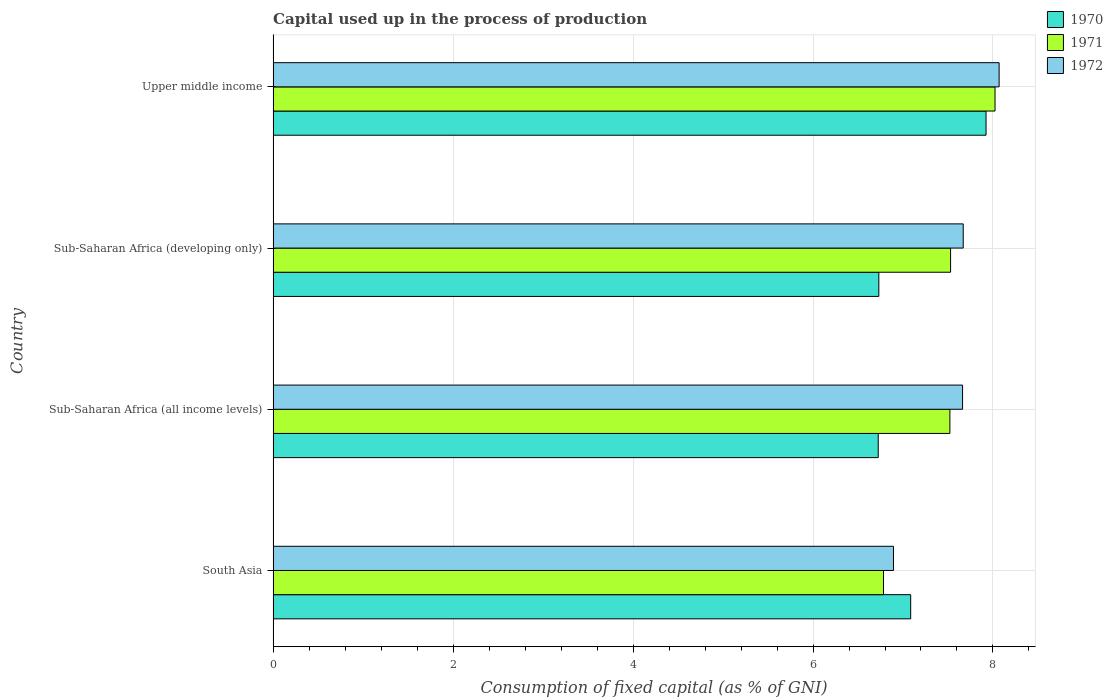How many groups of bars are there?
Ensure brevity in your answer.  4. How many bars are there on the 4th tick from the top?
Offer a terse response. 3. How many bars are there on the 2nd tick from the bottom?
Your response must be concise. 3. What is the label of the 2nd group of bars from the top?
Your response must be concise. Sub-Saharan Africa (developing only). What is the capital used up in the process of production in 1972 in South Asia?
Ensure brevity in your answer.  6.89. Across all countries, what is the maximum capital used up in the process of production in 1971?
Your response must be concise. 8.02. Across all countries, what is the minimum capital used up in the process of production in 1971?
Your answer should be compact. 6.78. In which country was the capital used up in the process of production in 1970 maximum?
Keep it short and to the point. Upper middle income. In which country was the capital used up in the process of production in 1970 minimum?
Keep it short and to the point. Sub-Saharan Africa (all income levels). What is the total capital used up in the process of production in 1972 in the graph?
Your response must be concise. 30.29. What is the difference between the capital used up in the process of production in 1970 in South Asia and that in Sub-Saharan Africa (developing only)?
Give a very brief answer. 0.35. What is the difference between the capital used up in the process of production in 1971 in Upper middle income and the capital used up in the process of production in 1970 in Sub-Saharan Africa (all income levels)?
Provide a short and direct response. 1.3. What is the average capital used up in the process of production in 1970 per country?
Offer a very short reply. 7.12. What is the difference between the capital used up in the process of production in 1970 and capital used up in the process of production in 1972 in Sub-Saharan Africa (all income levels)?
Give a very brief answer. -0.94. In how many countries, is the capital used up in the process of production in 1970 greater than 3.6 %?
Give a very brief answer. 4. What is the ratio of the capital used up in the process of production in 1970 in Sub-Saharan Africa (all income levels) to that in Sub-Saharan Africa (developing only)?
Offer a very short reply. 1. Is the capital used up in the process of production in 1970 in Sub-Saharan Africa (developing only) less than that in Upper middle income?
Make the answer very short. Yes. What is the difference between the highest and the second highest capital used up in the process of production in 1970?
Give a very brief answer. 0.84. What is the difference between the highest and the lowest capital used up in the process of production in 1970?
Keep it short and to the point. 1.2. What does the 3rd bar from the bottom in Upper middle income represents?
Provide a short and direct response. 1972. How many bars are there?
Provide a short and direct response. 12. How many countries are there in the graph?
Keep it short and to the point. 4. What is the difference between two consecutive major ticks on the X-axis?
Give a very brief answer. 2. Are the values on the major ticks of X-axis written in scientific E-notation?
Your answer should be compact. No. How are the legend labels stacked?
Provide a succinct answer. Vertical. What is the title of the graph?
Your answer should be compact. Capital used up in the process of production. Does "1960" appear as one of the legend labels in the graph?
Your response must be concise. No. What is the label or title of the X-axis?
Provide a short and direct response. Consumption of fixed capital (as % of GNI). What is the Consumption of fixed capital (as % of GNI) in 1970 in South Asia?
Ensure brevity in your answer.  7.09. What is the Consumption of fixed capital (as % of GNI) of 1971 in South Asia?
Your answer should be compact. 6.78. What is the Consumption of fixed capital (as % of GNI) of 1972 in South Asia?
Offer a very short reply. 6.89. What is the Consumption of fixed capital (as % of GNI) in 1970 in Sub-Saharan Africa (all income levels)?
Your answer should be compact. 6.72. What is the Consumption of fixed capital (as % of GNI) in 1971 in Sub-Saharan Africa (all income levels)?
Provide a short and direct response. 7.52. What is the Consumption of fixed capital (as % of GNI) in 1972 in Sub-Saharan Africa (all income levels)?
Give a very brief answer. 7.66. What is the Consumption of fixed capital (as % of GNI) of 1970 in Sub-Saharan Africa (developing only)?
Offer a terse response. 6.73. What is the Consumption of fixed capital (as % of GNI) of 1971 in Sub-Saharan Africa (developing only)?
Make the answer very short. 7.53. What is the Consumption of fixed capital (as % of GNI) of 1972 in Sub-Saharan Africa (developing only)?
Give a very brief answer. 7.67. What is the Consumption of fixed capital (as % of GNI) in 1970 in Upper middle income?
Give a very brief answer. 7.92. What is the Consumption of fixed capital (as % of GNI) in 1971 in Upper middle income?
Your answer should be very brief. 8.02. What is the Consumption of fixed capital (as % of GNI) in 1972 in Upper middle income?
Your answer should be compact. 8.07. Across all countries, what is the maximum Consumption of fixed capital (as % of GNI) in 1970?
Keep it short and to the point. 7.92. Across all countries, what is the maximum Consumption of fixed capital (as % of GNI) in 1971?
Offer a very short reply. 8.02. Across all countries, what is the maximum Consumption of fixed capital (as % of GNI) of 1972?
Your answer should be very brief. 8.07. Across all countries, what is the minimum Consumption of fixed capital (as % of GNI) of 1970?
Give a very brief answer. 6.72. Across all countries, what is the minimum Consumption of fixed capital (as % of GNI) in 1971?
Offer a very short reply. 6.78. Across all countries, what is the minimum Consumption of fixed capital (as % of GNI) in 1972?
Give a very brief answer. 6.89. What is the total Consumption of fixed capital (as % of GNI) of 1970 in the graph?
Your answer should be compact. 28.46. What is the total Consumption of fixed capital (as % of GNI) of 1971 in the graph?
Your answer should be very brief. 29.86. What is the total Consumption of fixed capital (as % of GNI) in 1972 in the graph?
Provide a succinct answer. 30.29. What is the difference between the Consumption of fixed capital (as % of GNI) of 1970 in South Asia and that in Sub-Saharan Africa (all income levels)?
Your answer should be compact. 0.36. What is the difference between the Consumption of fixed capital (as % of GNI) in 1971 in South Asia and that in Sub-Saharan Africa (all income levels)?
Offer a terse response. -0.74. What is the difference between the Consumption of fixed capital (as % of GNI) in 1972 in South Asia and that in Sub-Saharan Africa (all income levels)?
Provide a short and direct response. -0.77. What is the difference between the Consumption of fixed capital (as % of GNI) of 1970 in South Asia and that in Sub-Saharan Africa (developing only)?
Provide a short and direct response. 0.35. What is the difference between the Consumption of fixed capital (as % of GNI) in 1971 in South Asia and that in Sub-Saharan Africa (developing only)?
Your response must be concise. -0.75. What is the difference between the Consumption of fixed capital (as % of GNI) of 1972 in South Asia and that in Sub-Saharan Africa (developing only)?
Make the answer very short. -0.77. What is the difference between the Consumption of fixed capital (as % of GNI) in 1970 in South Asia and that in Upper middle income?
Your response must be concise. -0.84. What is the difference between the Consumption of fixed capital (as % of GNI) in 1971 in South Asia and that in Upper middle income?
Your response must be concise. -1.24. What is the difference between the Consumption of fixed capital (as % of GNI) of 1972 in South Asia and that in Upper middle income?
Provide a short and direct response. -1.17. What is the difference between the Consumption of fixed capital (as % of GNI) of 1970 in Sub-Saharan Africa (all income levels) and that in Sub-Saharan Africa (developing only)?
Make the answer very short. -0.01. What is the difference between the Consumption of fixed capital (as % of GNI) of 1971 in Sub-Saharan Africa (all income levels) and that in Sub-Saharan Africa (developing only)?
Offer a terse response. -0.01. What is the difference between the Consumption of fixed capital (as % of GNI) in 1972 in Sub-Saharan Africa (all income levels) and that in Sub-Saharan Africa (developing only)?
Your answer should be compact. -0.01. What is the difference between the Consumption of fixed capital (as % of GNI) of 1970 in Sub-Saharan Africa (all income levels) and that in Upper middle income?
Give a very brief answer. -1.2. What is the difference between the Consumption of fixed capital (as % of GNI) in 1971 in Sub-Saharan Africa (all income levels) and that in Upper middle income?
Your response must be concise. -0.5. What is the difference between the Consumption of fixed capital (as % of GNI) of 1972 in Sub-Saharan Africa (all income levels) and that in Upper middle income?
Your answer should be compact. -0.41. What is the difference between the Consumption of fixed capital (as % of GNI) of 1970 in Sub-Saharan Africa (developing only) and that in Upper middle income?
Offer a terse response. -1.19. What is the difference between the Consumption of fixed capital (as % of GNI) in 1971 in Sub-Saharan Africa (developing only) and that in Upper middle income?
Give a very brief answer. -0.49. What is the difference between the Consumption of fixed capital (as % of GNI) in 1972 in Sub-Saharan Africa (developing only) and that in Upper middle income?
Offer a terse response. -0.4. What is the difference between the Consumption of fixed capital (as % of GNI) of 1970 in South Asia and the Consumption of fixed capital (as % of GNI) of 1971 in Sub-Saharan Africa (all income levels)?
Provide a succinct answer. -0.44. What is the difference between the Consumption of fixed capital (as % of GNI) of 1970 in South Asia and the Consumption of fixed capital (as % of GNI) of 1972 in Sub-Saharan Africa (all income levels)?
Offer a very short reply. -0.58. What is the difference between the Consumption of fixed capital (as % of GNI) of 1971 in South Asia and the Consumption of fixed capital (as % of GNI) of 1972 in Sub-Saharan Africa (all income levels)?
Give a very brief answer. -0.88. What is the difference between the Consumption of fixed capital (as % of GNI) in 1970 in South Asia and the Consumption of fixed capital (as % of GNI) in 1971 in Sub-Saharan Africa (developing only)?
Your answer should be compact. -0.44. What is the difference between the Consumption of fixed capital (as % of GNI) of 1970 in South Asia and the Consumption of fixed capital (as % of GNI) of 1972 in Sub-Saharan Africa (developing only)?
Provide a succinct answer. -0.58. What is the difference between the Consumption of fixed capital (as % of GNI) of 1971 in South Asia and the Consumption of fixed capital (as % of GNI) of 1972 in Sub-Saharan Africa (developing only)?
Your answer should be very brief. -0.89. What is the difference between the Consumption of fixed capital (as % of GNI) in 1970 in South Asia and the Consumption of fixed capital (as % of GNI) in 1971 in Upper middle income?
Ensure brevity in your answer.  -0.94. What is the difference between the Consumption of fixed capital (as % of GNI) of 1970 in South Asia and the Consumption of fixed capital (as % of GNI) of 1972 in Upper middle income?
Keep it short and to the point. -0.98. What is the difference between the Consumption of fixed capital (as % of GNI) in 1971 in South Asia and the Consumption of fixed capital (as % of GNI) in 1972 in Upper middle income?
Ensure brevity in your answer.  -1.28. What is the difference between the Consumption of fixed capital (as % of GNI) of 1970 in Sub-Saharan Africa (all income levels) and the Consumption of fixed capital (as % of GNI) of 1971 in Sub-Saharan Africa (developing only)?
Provide a succinct answer. -0.8. What is the difference between the Consumption of fixed capital (as % of GNI) in 1970 in Sub-Saharan Africa (all income levels) and the Consumption of fixed capital (as % of GNI) in 1972 in Sub-Saharan Africa (developing only)?
Make the answer very short. -0.94. What is the difference between the Consumption of fixed capital (as % of GNI) of 1971 in Sub-Saharan Africa (all income levels) and the Consumption of fixed capital (as % of GNI) of 1972 in Sub-Saharan Africa (developing only)?
Your answer should be compact. -0.15. What is the difference between the Consumption of fixed capital (as % of GNI) in 1970 in Sub-Saharan Africa (all income levels) and the Consumption of fixed capital (as % of GNI) in 1971 in Upper middle income?
Ensure brevity in your answer.  -1.3. What is the difference between the Consumption of fixed capital (as % of GNI) of 1970 in Sub-Saharan Africa (all income levels) and the Consumption of fixed capital (as % of GNI) of 1972 in Upper middle income?
Keep it short and to the point. -1.34. What is the difference between the Consumption of fixed capital (as % of GNI) of 1971 in Sub-Saharan Africa (all income levels) and the Consumption of fixed capital (as % of GNI) of 1972 in Upper middle income?
Your response must be concise. -0.55. What is the difference between the Consumption of fixed capital (as % of GNI) in 1970 in Sub-Saharan Africa (developing only) and the Consumption of fixed capital (as % of GNI) in 1971 in Upper middle income?
Offer a terse response. -1.29. What is the difference between the Consumption of fixed capital (as % of GNI) of 1970 in Sub-Saharan Africa (developing only) and the Consumption of fixed capital (as % of GNI) of 1972 in Upper middle income?
Offer a terse response. -1.34. What is the difference between the Consumption of fixed capital (as % of GNI) in 1971 in Sub-Saharan Africa (developing only) and the Consumption of fixed capital (as % of GNI) in 1972 in Upper middle income?
Your answer should be very brief. -0.54. What is the average Consumption of fixed capital (as % of GNI) in 1970 per country?
Offer a very short reply. 7.12. What is the average Consumption of fixed capital (as % of GNI) in 1971 per country?
Provide a short and direct response. 7.46. What is the average Consumption of fixed capital (as % of GNI) of 1972 per country?
Give a very brief answer. 7.57. What is the difference between the Consumption of fixed capital (as % of GNI) in 1970 and Consumption of fixed capital (as % of GNI) in 1971 in South Asia?
Keep it short and to the point. 0.3. What is the difference between the Consumption of fixed capital (as % of GNI) in 1970 and Consumption of fixed capital (as % of GNI) in 1972 in South Asia?
Provide a succinct answer. 0.19. What is the difference between the Consumption of fixed capital (as % of GNI) of 1971 and Consumption of fixed capital (as % of GNI) of 1972 in South Asia?
Offer a terse response. -0.11. What is the difference between the Consumption of fixed capital (as % of GNI) of 1970 and Consumption of fixed capital (as % of GNI) of 1971 in Sub-Saharan Africa (all income levels)?
Give a very brief answer. -0.8. What is the difference between the Consumption of fixed capital (as % of GNI) in 1970 and Consumption of fixed capital (as % of GNI) in 1972 in Sub-Saharan Africa (all income levels)?
Give a very brief answer. -0.94. What is the difference between the Consumption of fixed capital (as % of GNI) in 1971 and Consumption of fixed capital (as % of GNI) in 1972 in Sub-Saharan Africa (all income levels)?
Offer a very short reply. -0.14. What is the difference between the Consumption of fixed capital (as % of GNI) in 1970 and Consumption of fixed capital (as % of GNI) in 1971 in Sub-Saharan Africa (developing only)?
Provide a succinct answer. -0.8. What is the difference between the Consumption of fixed capital (as % of GNI) of 1970 and Consumption of fixed capital (as % of GNI) of 1972 in Sub-Saharan Africa (developing only)?
Give a very brief answer. -0.94. What is the difference between the Consumption of fixed capital (as % of GNI) of 1971 and Consumption of fixed capital (as % of GNI) of 1972 in Sub-Saharan Africa (developing only)?
Keep it short and to the point. -0.14. What is the difference between the Consumption of fixed capital (as % of GNI) of 1970 and Consumption of fixed capital (as % of GNI) of 1971 in Upper middle income?
Provide a succinct answer. -0.1. What is the difference between the Consumption of fixed capital (as % of GNI) of 1970 and Consumption of fixed capital (as % of GNI) of 1972 in Upper middle income?
Make the answer very short. -0.15. What is the difference between the Consumption of fixed capital (as % of GNI) of 1971 and Consumption of fixed capital (as % of GNI) of 1972 in Upper middle income?
Give a very brief answer. -0.05. What is the ratio of the Consumption of fixed capital (as % of GNI) in 1970 in South Asia to that in Sub-Saharan Africa (all income levels)?
Keep it short and to the point. 1.05. What is the ratio of the Consumption of fixed capital (as % of GNI) of 1971 in South Asia to that in Sub-Saharan Africa (all income levels)?
Your answer should be very brief. 0.9. What is the ratio of the Consumption of fixed capital (as % of GNI) in 1972 in South Asia to that in Sub-Saharan Africa (all income levels)?
Provide a succinct answer. 0.9. What is the ratio of the Consumption of fixed capital (as % of GNI) of 1970 in South Asia to that in Sub-Saharan Africa (developing only)?
Offer a very short reply. 1.05. What is the ratio of the Consumption of fixed capital (as % of GNI) of 1971 in South Asia to that in Sub-Saharan Africa (developing only)?
Provide a short and direct response. 0.9. What is the ratio of the Consumption of fixed capital (as % of GNI) in 1972 in South Asia to that in Sub-Saharan Africa (developing only)?
Ensure brevity in your answer.  0.9. What is the ratio of the Consumption of fixed capital (as % of GNI) in 1970 in South Asia to that in Upper middle income?
Ensure brevity in your answer.  0.89. What is the ratio of the Consumption of fixed capital (as % of GNI) of 1971 in South Asia to that in Upper middle income?
Give a very brief answer. 0.85. What is the ratio of the Consumption of fixed capital (as % of GNI) of 1972 in South Asia to that in Upper middle income?
Offer a very short reply. 0.85. What is the ratio of the Consumption of fixed capital (as % of GNI) in 1970 in Sub-Saharan Africa (all income levels) to that in Sub-Saharan Africa (developing only)?
Provide a short and direct response. 1. What is the ratio of the Consumption of fixed capital (as % of GNI) in 1971 in Sub-Saharan Africa (all income levels) to that in Sub-Saharan Africa (developing only)?
Provide a short and direct response. 1. What is the ratio of the Consumption of fixed capital (as % of GNI) in 1972 in Sub-Saharan Africa (all income levels) to that in Sub-Saharan Africa (developing only)?
Your answer should be compact. 1. What is the ratio of the Consumption of fixed capital (as % of GNI) of 1970 in Sub-Saharan Africa (all income levels) to that in Upper middle income?
Provide a succinct answer. 0.85. What is the ratio of the Consumption of fixed capital (as % of GNI) in 1972 in Sub-Saharan Africa (all income levels) to that in Upper middle income?
Your answer should be compact. 0.95. What is the ratio of the Consumption of fixed capital (as % of GNI) of 1970 in Sub-Saharan Africa (developing only) to that in Upper middle income?
Your answer should be compact. 0.85. What is the ratio of the Consumption of fixed capital (as % of GNI) in 1971 in Sub-Saharan Africa (developing only) to that in Upper middle income?
Ensure brevity in your answer.  0.94. What is the ratio of the Consumption of fixed capital (as % of GNI) in 1972 in Sub-Saharan Africa (developing only) to that in Upper middle income?
Offer a terse response. 0.95. What is the difference between the highest and the second highest Consumption of fixed capital (as % of GNI) in 1970?
Give a very brief answer. 0.84. What is the difference between the highest and the second highest Consumption of fixed capital (as % of GNI) of 1971?
Offer a terse response. 0.49. What is the difference between the highest and the second highest Consumption of fixed capital (as % of GNI) in 1972?
Your answer should be very brief. 0.4. What is the difference between the highest and the lowest Consumption of fixed capital (as % of GNI) of 1970?
Make the answer very short. 1.2. What is the difference between the highest and the lowest Consumption of fixed capital (as % of GNI) in 1971?
Your answer should be very brief. 1.24. What is the difference between the highest and the lowest Consumption of fixed capital (as % of GNI) of 1972?
Give a very brief answer. 1.17. 